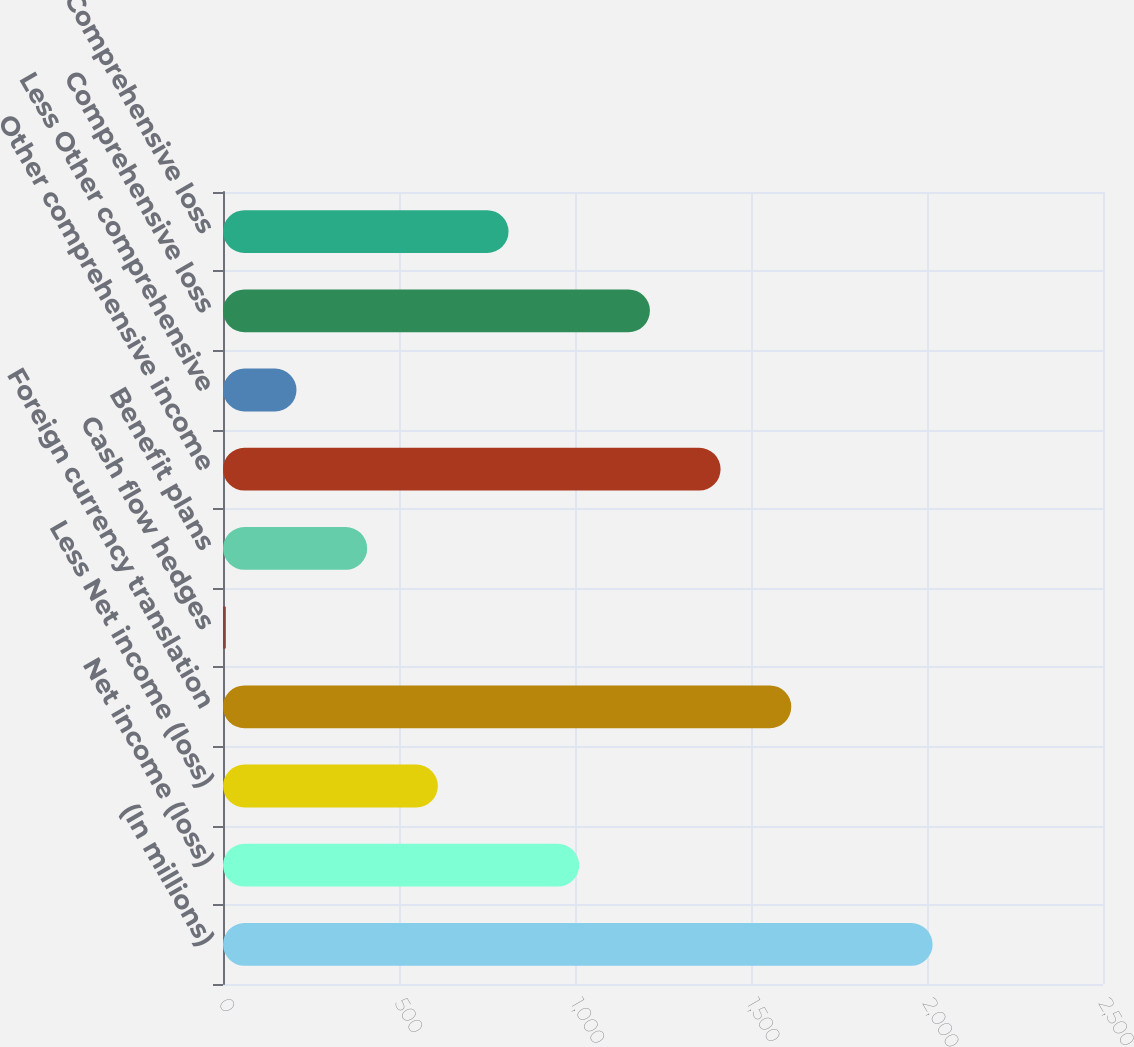Convert chart to OTSL. <chart><loc_0><loc_0><loc_500><loc_500><bar_chart><fcel>(In millions)<fcel>Net income (loss)<fcel>Less Net income (loss)<fcel>Foreign currency translation<fcel>Cash flow hedges<fcel>Benefit plans<fcel>Other comprehensive income<fcel>Less Other comprehensive<fcel>Comprehensive loss<fcel>Less Comprehensive loss<nl><fcel>2016<fcel>1012<fcel>610.4<fcel>1614.4<fcel>8<fcel>409.6<fcel>1413.6<fcel>208.8<fcel>1212.8<fcel>811.2<nl></chart> 